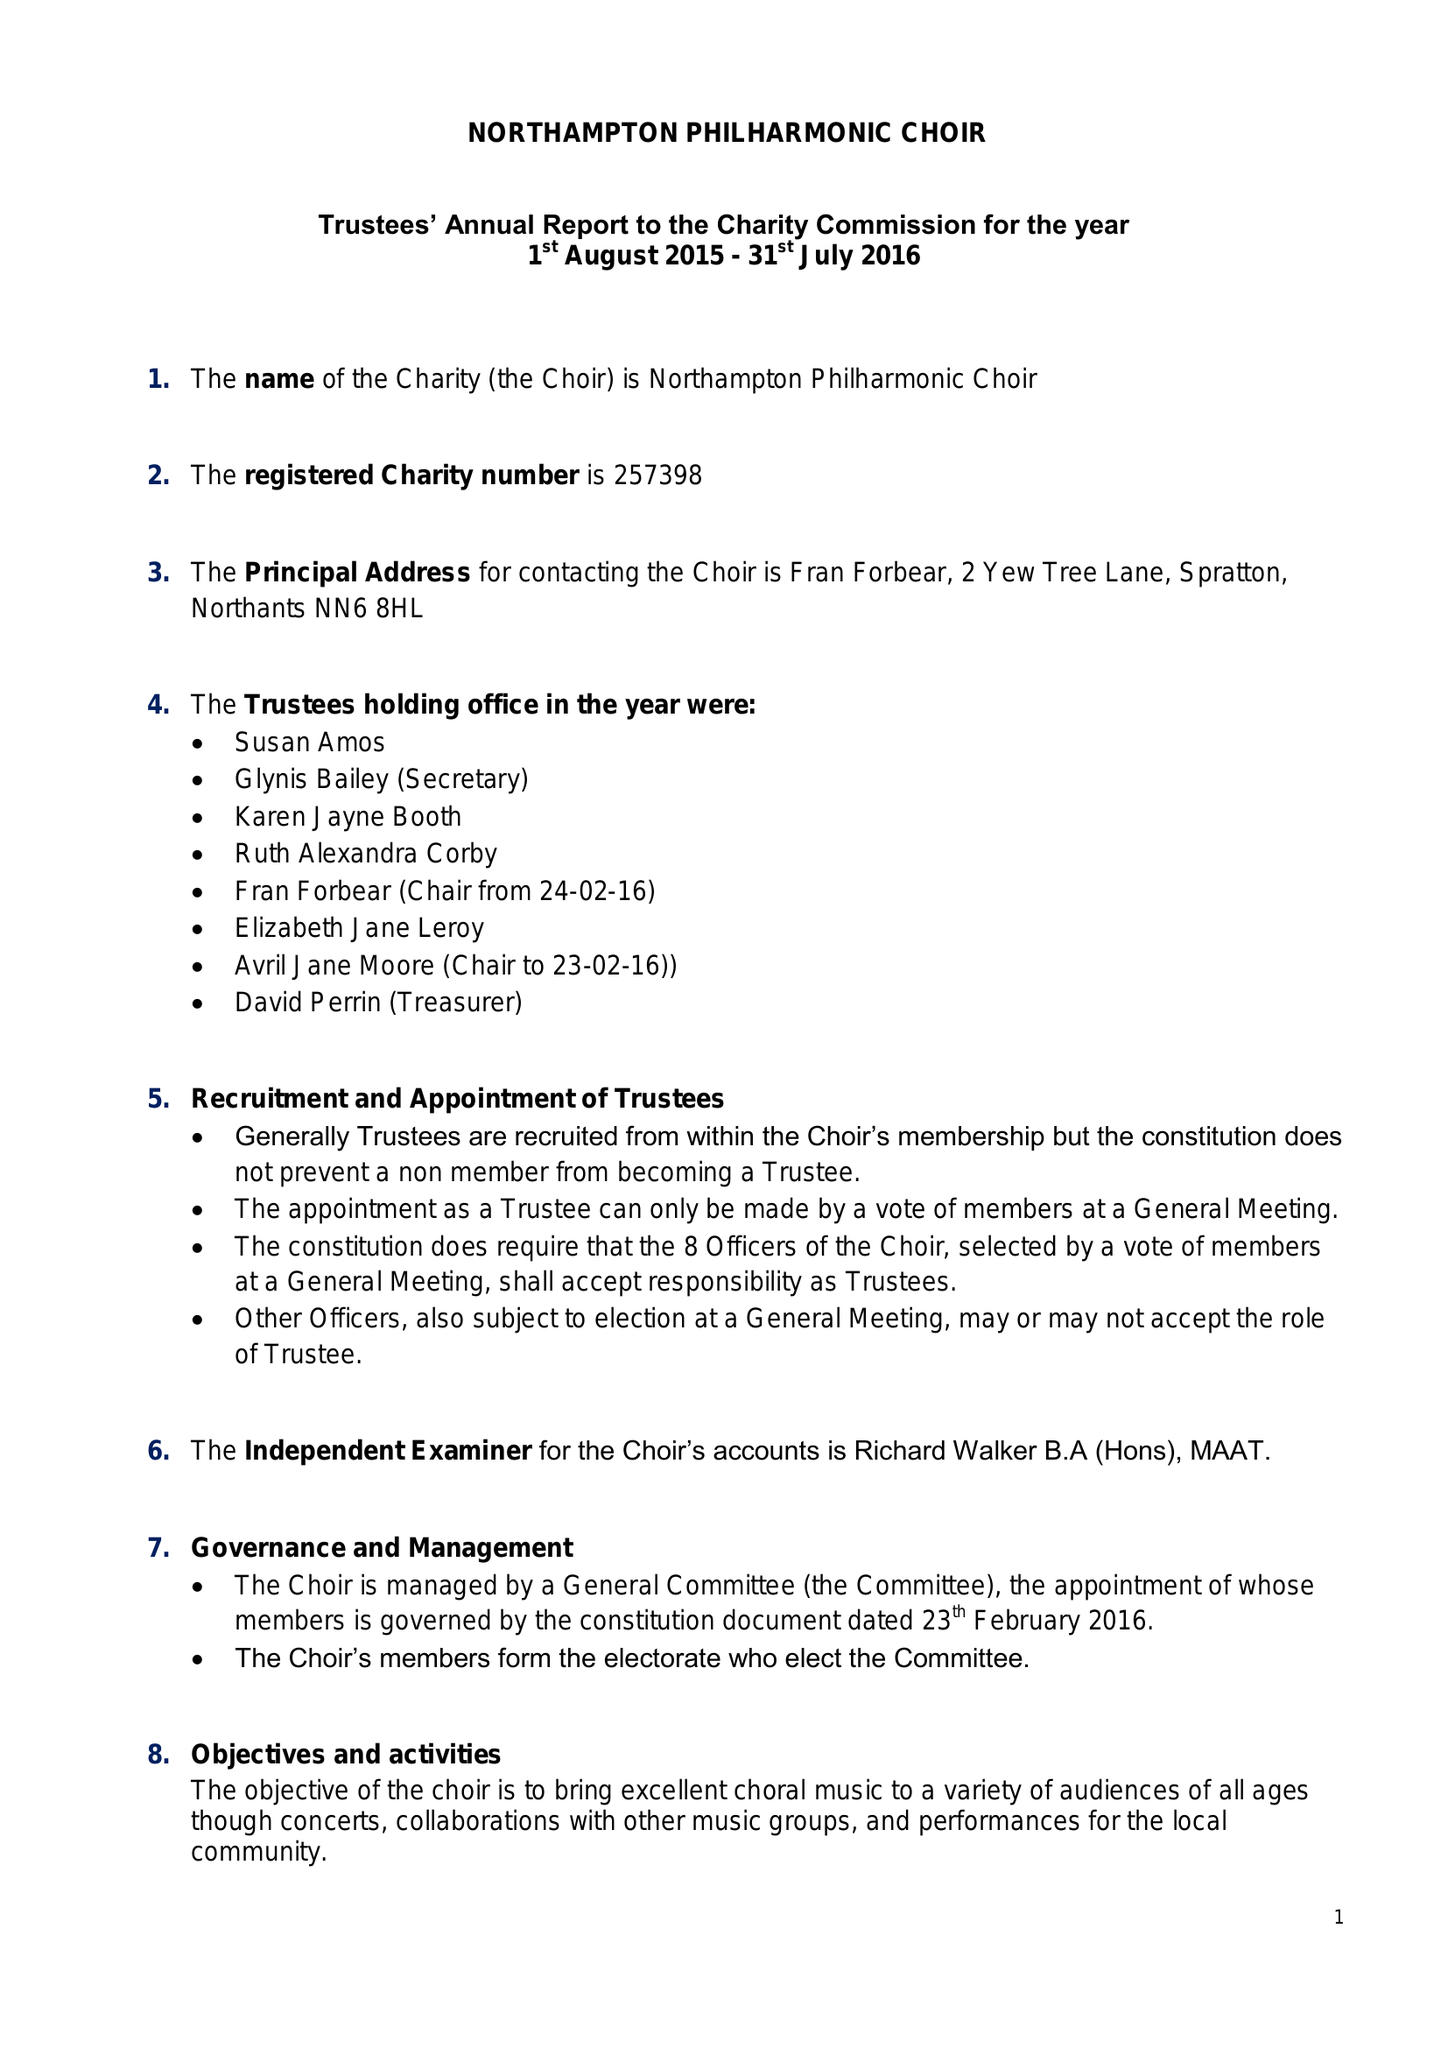What is the value for the address__postcode?
Answer the question using a single word or phrase. NN6 8HL 